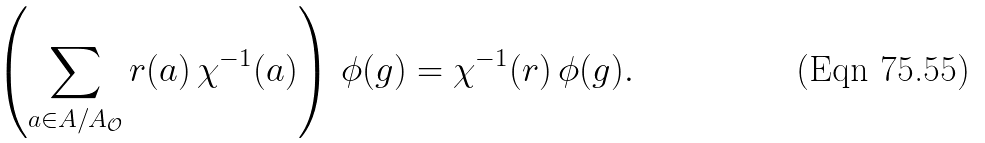Convert formula to latex. <formula><loc_0><loc_0><loc_500><loc_500>\left ( \sum _ { a \in A / A _ { \mathcal { O } } } r ( a ) \, \chi ^ { - 1 } ( a ) \right ) \, \phi ( g ) = \chi ^ { - 1 } ( r ) \, \phi ( g ) .</formula> 